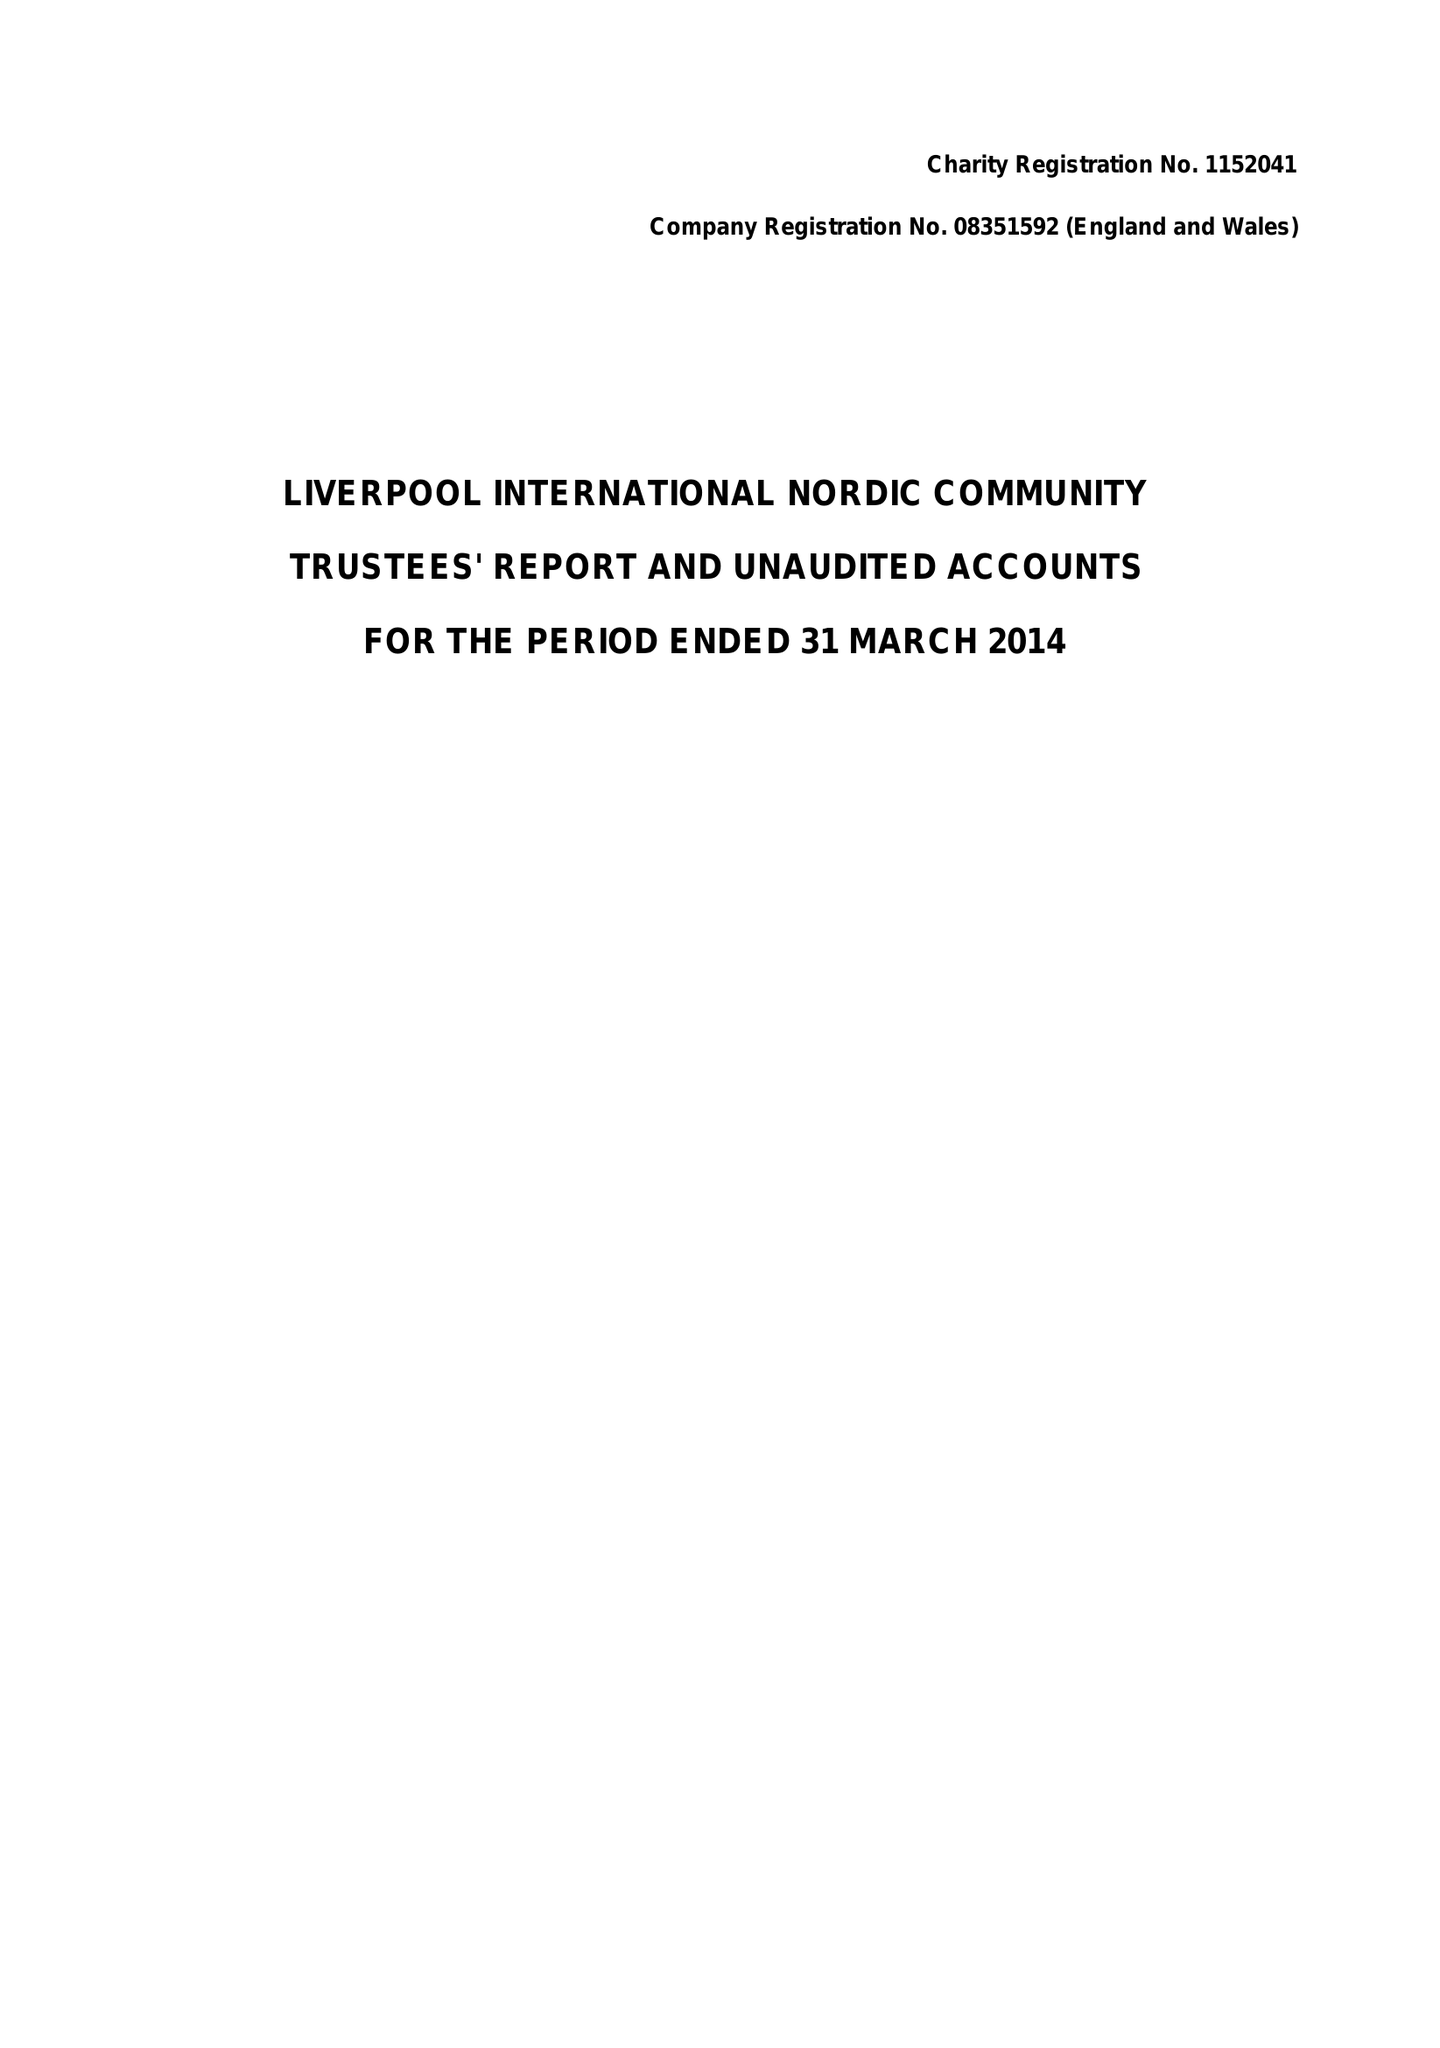What is the value for the income_annually_in_british_pounds?
Answer the question using a single word or phrase. 41245.00 